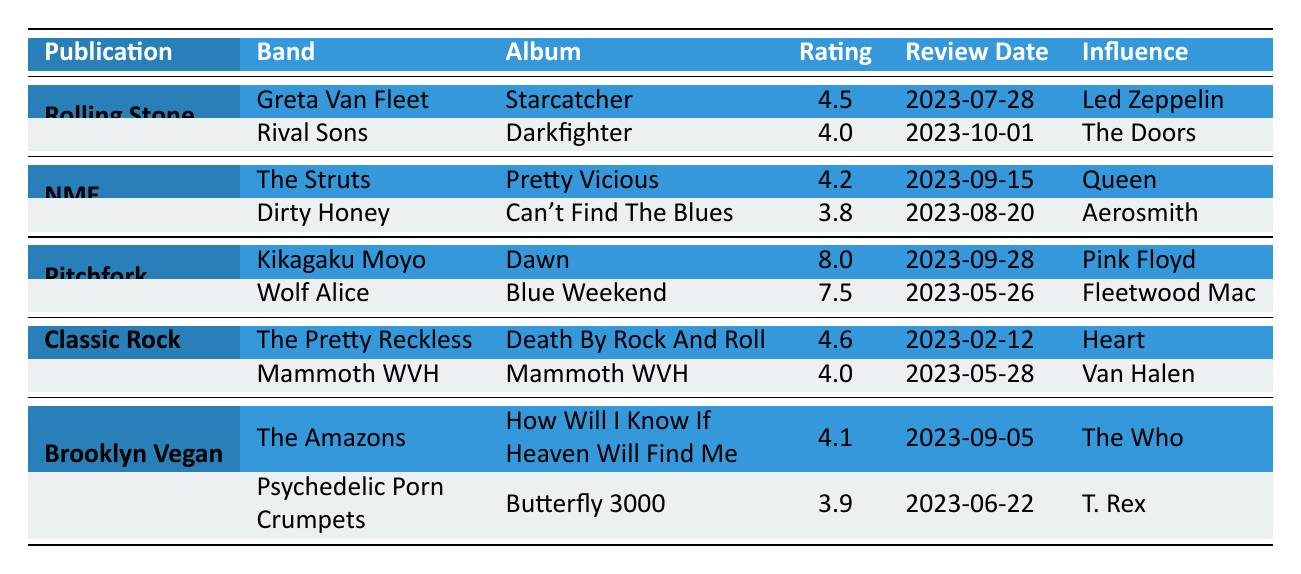What is the highest rating in the table? The table shows multiple ratings across different bands and albums. The highest rating is 8.0 for the album "Dawn" by Kikagaku Moyo.
Answer: 8.0 Which band received a rating of 4.6? The band "The Pretty Reckless" received a rating of 4.6 for their album "Death By Rock And Roll".
Answer: The Pretty Reckless How many publications reviewed new bands influenced by classic rock? There are 5 publications listed in the table: Rolling Stone, NME, Pitchfork, Classic Rock Magazine, and Brooklyn Vegan.
Answer: 5 Is there a band influenced by The Doors in the table? Yes, Rival Sons is influenced by The Doors as noted in their review.
Answer: Yes What is the average rating for albums reviewed by Classic Rock Magazine? The ratings for Classic Rock Magazine are 4.6 and 4.0. To find the average, sum these ratings (4.6 + 4.0 = 8.6) and divide by the number of reviews (2), which gives 8.6 / 2 = 4.3.
Answer: 4.3 Which band has the highest influence rating from NME? NME reviewed The Struts with a rating of 4.2 and Dirty Honey at 3.8. The higher rating of 4.2 means The Struts has the highest rating from NME.
Answer: The Struts Based on the table, which band had the lowest rating? The lowest rating in the table is 3.8 for Dirty Honey. Comparatively, all other ratings are higher than this.
Answer: Dirty Honey How many bands have a rating of 4.0 or higher? The bands with ratings of 4.0 or higher are Greta Van Fleet (4.5), Rival Sons (4.0), The Struts (4.2), The Pretty Reckless (4.6), Mammoth WVH (4.0), and The Amazons (4.1). Counting them gives a total of 6 bands.
Answer: 6 What are the influences of the two bands reviewed by Pitchfork? Kikagaku Moyo is influenced by Pink Floyd, and Wolf Alice is influenced by Fleetwood Mac. Both influences are stated in the respective reviews.
Answer: Pink Floyd and Fleetwood Mac If we consider only the bands influenced by Heart and Aerosmith, which has the higher rating? The Pretty Reckless, influenced by Heart, has a rating of 4.6, and Dirty Honey, influenced by Aerosmith, has a rating of 3.8. Comparing these ratings shows that 4.6 (The Pretty Reckless) is higher than 3.8 (Dirty Honey).
Answer: The Pretty Reckless 